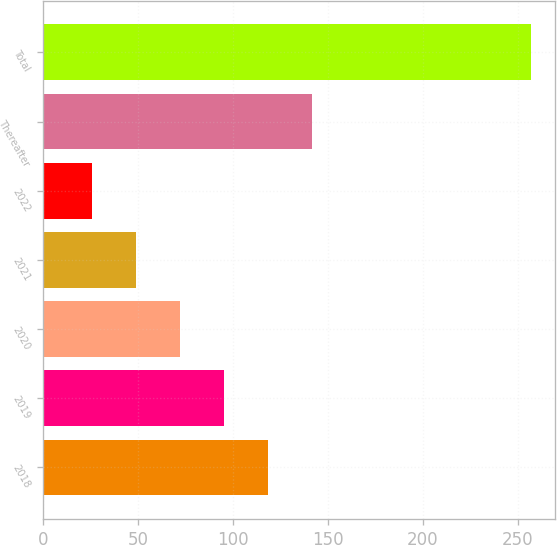<chart> <loc_0><loc_0><loc_500><loc_500><bar_chart><fcel>2018<fcel>2019<fcel>2020<fcel>2021<fcel>2022<fcel>Thereafter<fcel>Total<nl><fcel>118.18<fcel>95.06<fcel>71.94<fcel>48.82<fcel>25.7<fcel>141.3<fcel>256.9<nl></chart> 